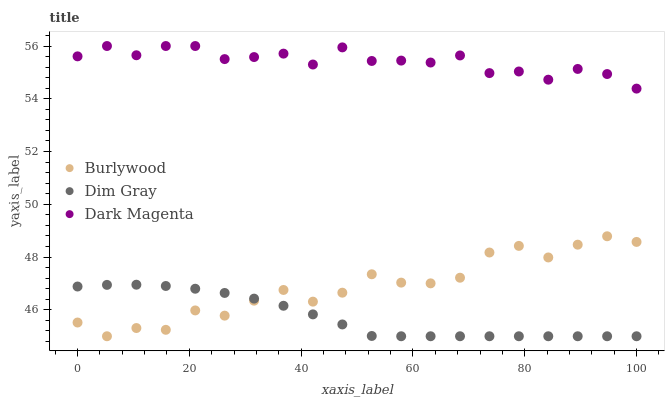Does Dim Gray have the minimum area under the curve?
Answer yes or no. Yes. Does Dark Magenta have the maximum area under the curve?
Answer yes or no. Yes. Does Dark Magenta have the minimum area under the curve?
Answer yes or no. No. Does Dim Gray have the maximum area under the curve?
Answer yes or no. No. Is Dim Gray the smoothest?
Answer yes or no. Yes. Is Burlywood the roughest?
Answer yes or no. Yes. Is Dark Magenta the smoothest?
Answer yes or no. No. Is Dark Magenta the roughest?
Answer yes or no. No. Does Burlywood have the lowest value?
Answer yes or no. Yes. Does Dark Magenta have the lowest value?
Answer yes or no. No. Does Dark Magenta have the highest value?
Answer yes or no. Yes. Does Dim Gray have the highest value?
Answer yes or no. No. Is Burlywood less than Dark Magenta?
Answer yes or no. Yes. Is Dark Magenta greater than Burlywood?
Answer yes or no. Yes. Does Burlywood intersect Dim Gray?
Answer yes or no. Yes. Is Burlywood less than Dim Gray?
Answer yes or no. No. Is Burlywood greater than Dim Gray?
Answer yes or no. No. Does Burlywood intersect Dark Magenta?
Answer yes or no. No. 